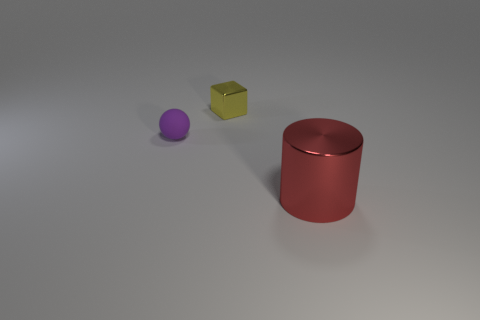What material is the ball?
Provide a short and direct response. Rubber. There is a tiny thing in front of the metallic thing that is to the left of the metal object that is in front of the yellow cube; what is its material?
Offer a terse response. Rubber. There is a yellow metallic object that is the same size as the matte sphere; what shape is it?
Your response must be concise. Cube. How many objects are tiny metal cubes or objects that are in front of the small metal cube?
Offer a terse response. 3. Are the object to the right of the metallic block and the tiny object to the right of the purple rubber sphere made of the same material?
Your answer should be very brief. Yes. How many gray things are tiny matte cylinders or big metallic cylinders?
Ensure brevity in your answer.  0. How big is the yellow metallic block?
Your answer should be very brief. Small. Are there more tiny yellow cubes right of the cylinder than red matte cylinders?
Offer a terse response. No. There is a tiny purple rubber thing; what number of small balls are on the left side of it?
Offer a terse response. 0. Are there any red metallic cylinders of the same size as the yellow metallic block?
Make the answer very short. No. 